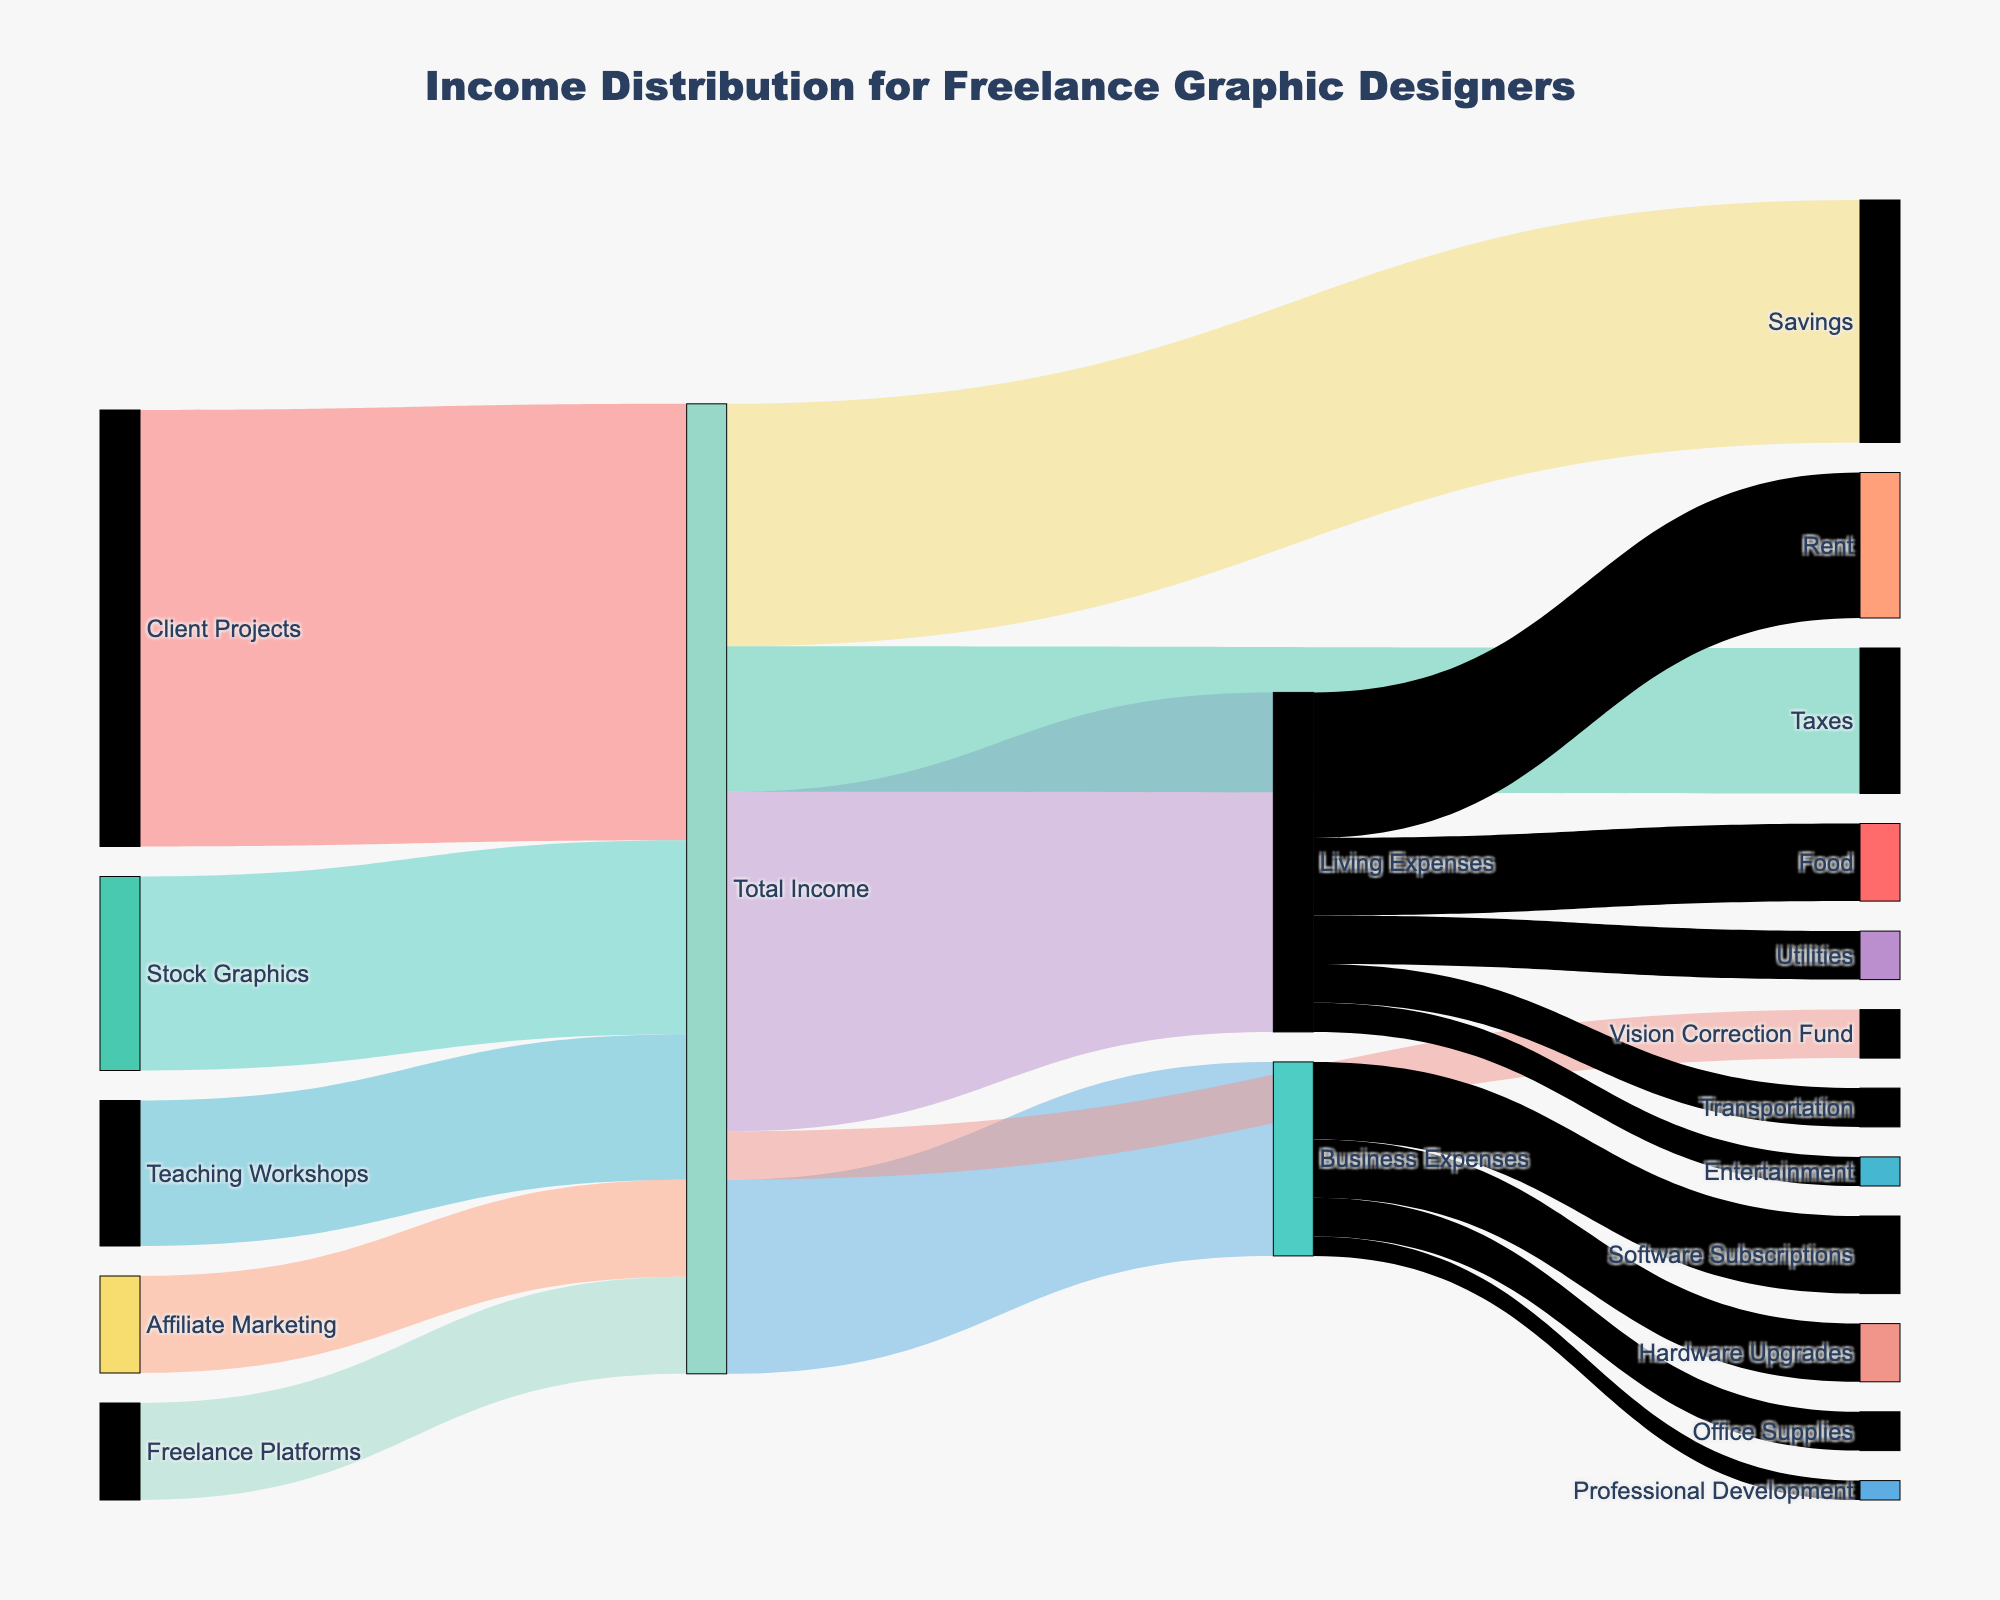what are the main sources of income for freelance graphic designers? The Sankey diagram shows several sources of income: Client Projects, Stock Graphics, Teaching Workshops, Affiliate Marketing, and Freelance Platforms.
Answer: Client Projects, Stock Graphics, Teaching Workshops, Affiliate Marketing, Freelance Platforms which source contributes the most to the total income? By looking at the width of the flows leading into Total Income, Client Projects contribute the most with a value of 45.
Answer: Client Projects what percentage of total income is saved? The flow from Total Income to Savings is 25. The total income is the sum of the contributions: 45 (Client Projects) + 20 (Stock Graphics) + 15 (Teaching Workshops) + 10 (Affiliate Marketing) + 10 (Freelance Platforms) = 100. Hence, the percentage of income saved is (25/100)*100% = 25%.
Answer: 25% which expense category has the highest value? The flows from Total Income to various expense categories indicate that Living Expenses have the highest value at 35.
Answer: Living Expenses how does the income from stock graphics compare to teaching workshops? The flows into Total Income show that income from Stock Graphics is 20 and from Teaching Workshops is 15. Stock Graphics generates 5 more in income than Teaching Workshops.
Answer: Stock Graphics generates more which subcategory of business expenses is the largest? Within Business Expenses, the largest subcategory is Software Subscriptions with a value of 8.
Answer: Software Subscriptions what is the total amount allocated to business expenses and living expenses combined? Adding the values for Business Expenses (20) and Living Expenses (35) gives a total of 55.
Answer: 55 how much is allocated to rent and food together under living expenses? The values for Rent and Food under Living Expenses are 15 and 8, respectively. Their sum is 15 + 8 = 23.
Answer: 23 what is the total contribution of all streams to the vision correction fund? The flow from Total Income to Vision Correction Fund is 5. Since it directly stems from Total Income, this is the sole contribution.
Answer: 5 